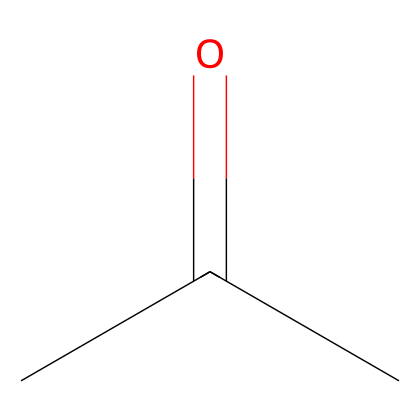What is the molecular formula of acetone? The SMILES representation "CC(=O)C" shows three carbon atoms (C) and one oxygen atom (O) attached to a carbon with a double bond. Therefore, the molecular formula can be derived from the counts of these atoms.
Answer: C3H6O How many hydrogen atoms are present in the chemical structure? Analyzing the SMILES "CC(=O)C," we see that each carbon (C) typically forms four bonds. The two outer carbon atoms are bonded to three hydrogen atoms collectively, while the central carbon is double-bonded to oxygen and bonded to one other carbon, leading to six hydrogen atoms total.
Answer: 6 What type of functional group is present in acetone? The "C(=O)" part of the SMILES represents a carbonyl group, which is characteristic of ketones. Acetone has the carbonyl group within a carbon chain, distinguishing it as a ketone.
Answer: carbonyl What is the total number of bonds represented in the structure? The structure represented by the SMILES has two carbon-carbon single bonds and one carbon-oxygen double bond, giving a total of four bonds (2 single + 1 double) visible in the molecule.
Answer: 4 Which part of the molecule indicates it is a ketone? The presence of a carbonyl group (C=O) in the structure indicates that the molecule is a ketone. This group is not at the end of the carbon chain, which is typical for ketones.
Answer: carbonyl group How many different types of atoms are in the molecule? By examining the SMILES, we identify carbon (C) and oxygen (O) as the different types of atoms present in acetone. Therefore, the molecule contains two distinct types of atoms.
Answer: 2 